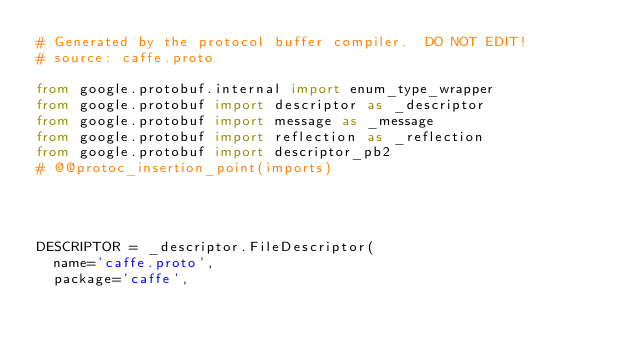Convert code to text. <code><loc_0><loc_0><loc_500><loc_500><_Python_># Generated by the protocol buffer compiler.  DO NOT EDIT!
# source: caffe.proto

from google.protobuf.internal import enum_type_wrapper
from google.protobuf import descriptor as _descriptor
from google.protobuf import message as _message
from google.protobuf import reflection as _reflection
from google.protobuf import descriptor_pb2
# @@protoc_insertion_point(imports)




DESCRIPTOR = _descriptor.FileDescriptor(
  name='caffe.proto',
  package='caffe',</code> 